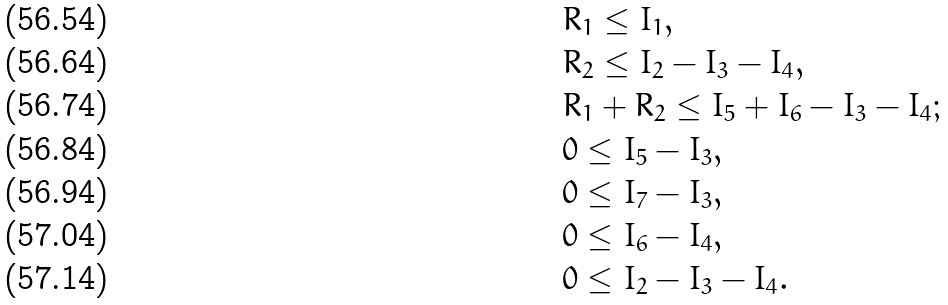<formula> <loc_0><loc_0><loc_500><loc_500>& R _ { 1 } \leq I _ { 1 } , \\ & R _ { 2 } \leq I _ { 2 } - I _ { 3 } - I _ { 4 } , \\ & R _ { 1 } + R _ { 2 } \leq I _ { 5 } + I _ { 6 } - I _ { 3 } - I _ { 4 } ; \\ & 0 \leq I _ { 5 } - I _ { 3 } , \\ & 0 \leq I _ { 7 } - I _ { 3 } , \\ & 0 \leq I _ { 6 } - I _ { 4 } , \\ & 0 \leq I _ { 2 } - I _ { 3 } - I _ { 4 } .</formula> 